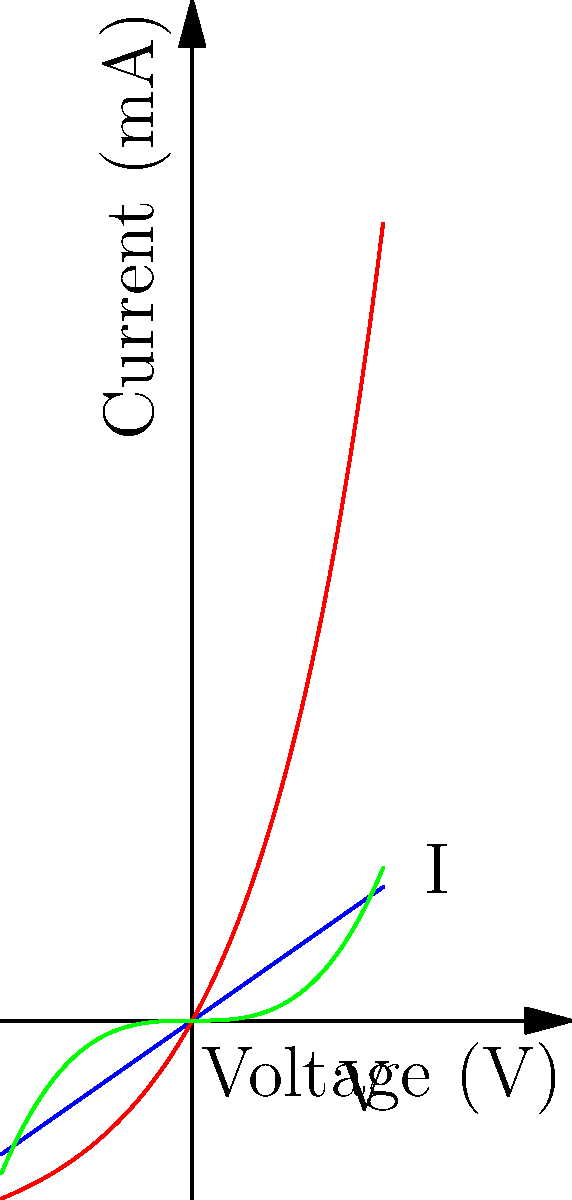In the characteristic curves shown above, which diode exhibits the most linear behavior in the forward bias region, and how might this property be relevant to the preservation of traditional Nepalese musical instruments? To answer this question, let's analyze the curves step-by-step:

1. The blue line represents a Schottky diode, which shows a nearly linear relationship between current and voltage.
2. The red curve represents a PN junction diode, which has an exponential relationship between current and voltage.
3. The green curve represents a Tunnel diode, which has a more complex, non-linear relationship.

The Schottky diode (blue line) exhibits the most linear behavior in the forward bias region. This linearity is crucial for our cultural context:

1. Linear response in electronics often translates to less distortion in signal processing.
2. Many traditional Nepalese instruments, such as the sarangi or madal, produce complex harmonic structures.
3. When recording or amplifying these instruments, maintaining the integrity of their unique timbres is essential for preserving their cultural significance.
4. A Schottky diode's linear behavior in circuits used for audio processing (e.g., in preamplifiers or effects units) would help maintain the authentic sound of these instruments.
5. This preserves the nuanced tonal qualities that are integral to Nepalese musical traditions, ensuring that modern recordings and performances accurately represent the cultural heritage.

Thus, the Schottky diode's linear characteristics make it valuable for audio applications where preserving the authentic sound of traditional Nepalese instruments is paramount.
Answer: Schottky diode; its linearity helps preserve authentic timbres of traditional Nepalese instruments in modern audio processing. 